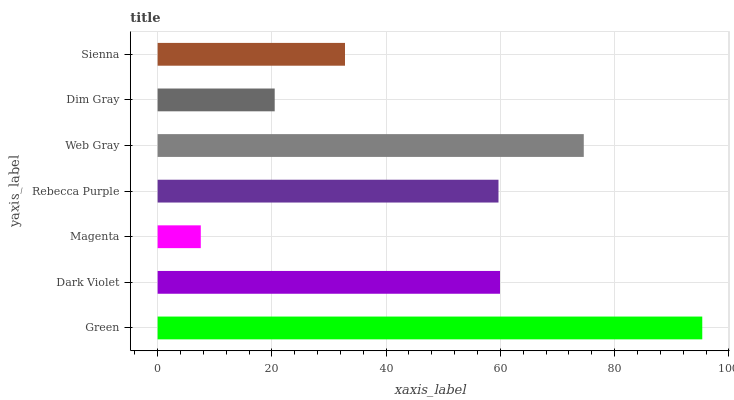Is Magenta the minimum?
Answer yes or no. Yes. Is Green the maximum?
Answer yes or no. Yes. Is Dark Violet the minimum?
Answer yes or no. No. Is Dark Violet the maximum?
Answer yes or no. No. Is Green greater than Dark Violet?
Answer yes or no. Yes. Is Dark Violet less than Green?
Answer yes or no. Yes. Is Dark Violet greater than Green?
Answer yes or no. No. Is Green less than Dark Violet?
Answer yes or no. No. Is Rebecca Purple the high median?
Answer yes or no. Yes. Is Rebecca Purple the low median?
Answer yes or no. Yes. Is Dim Gray the high median?
Answer yes or no. No. Is Dim Gray the low median?
Answer yes or no. No. 